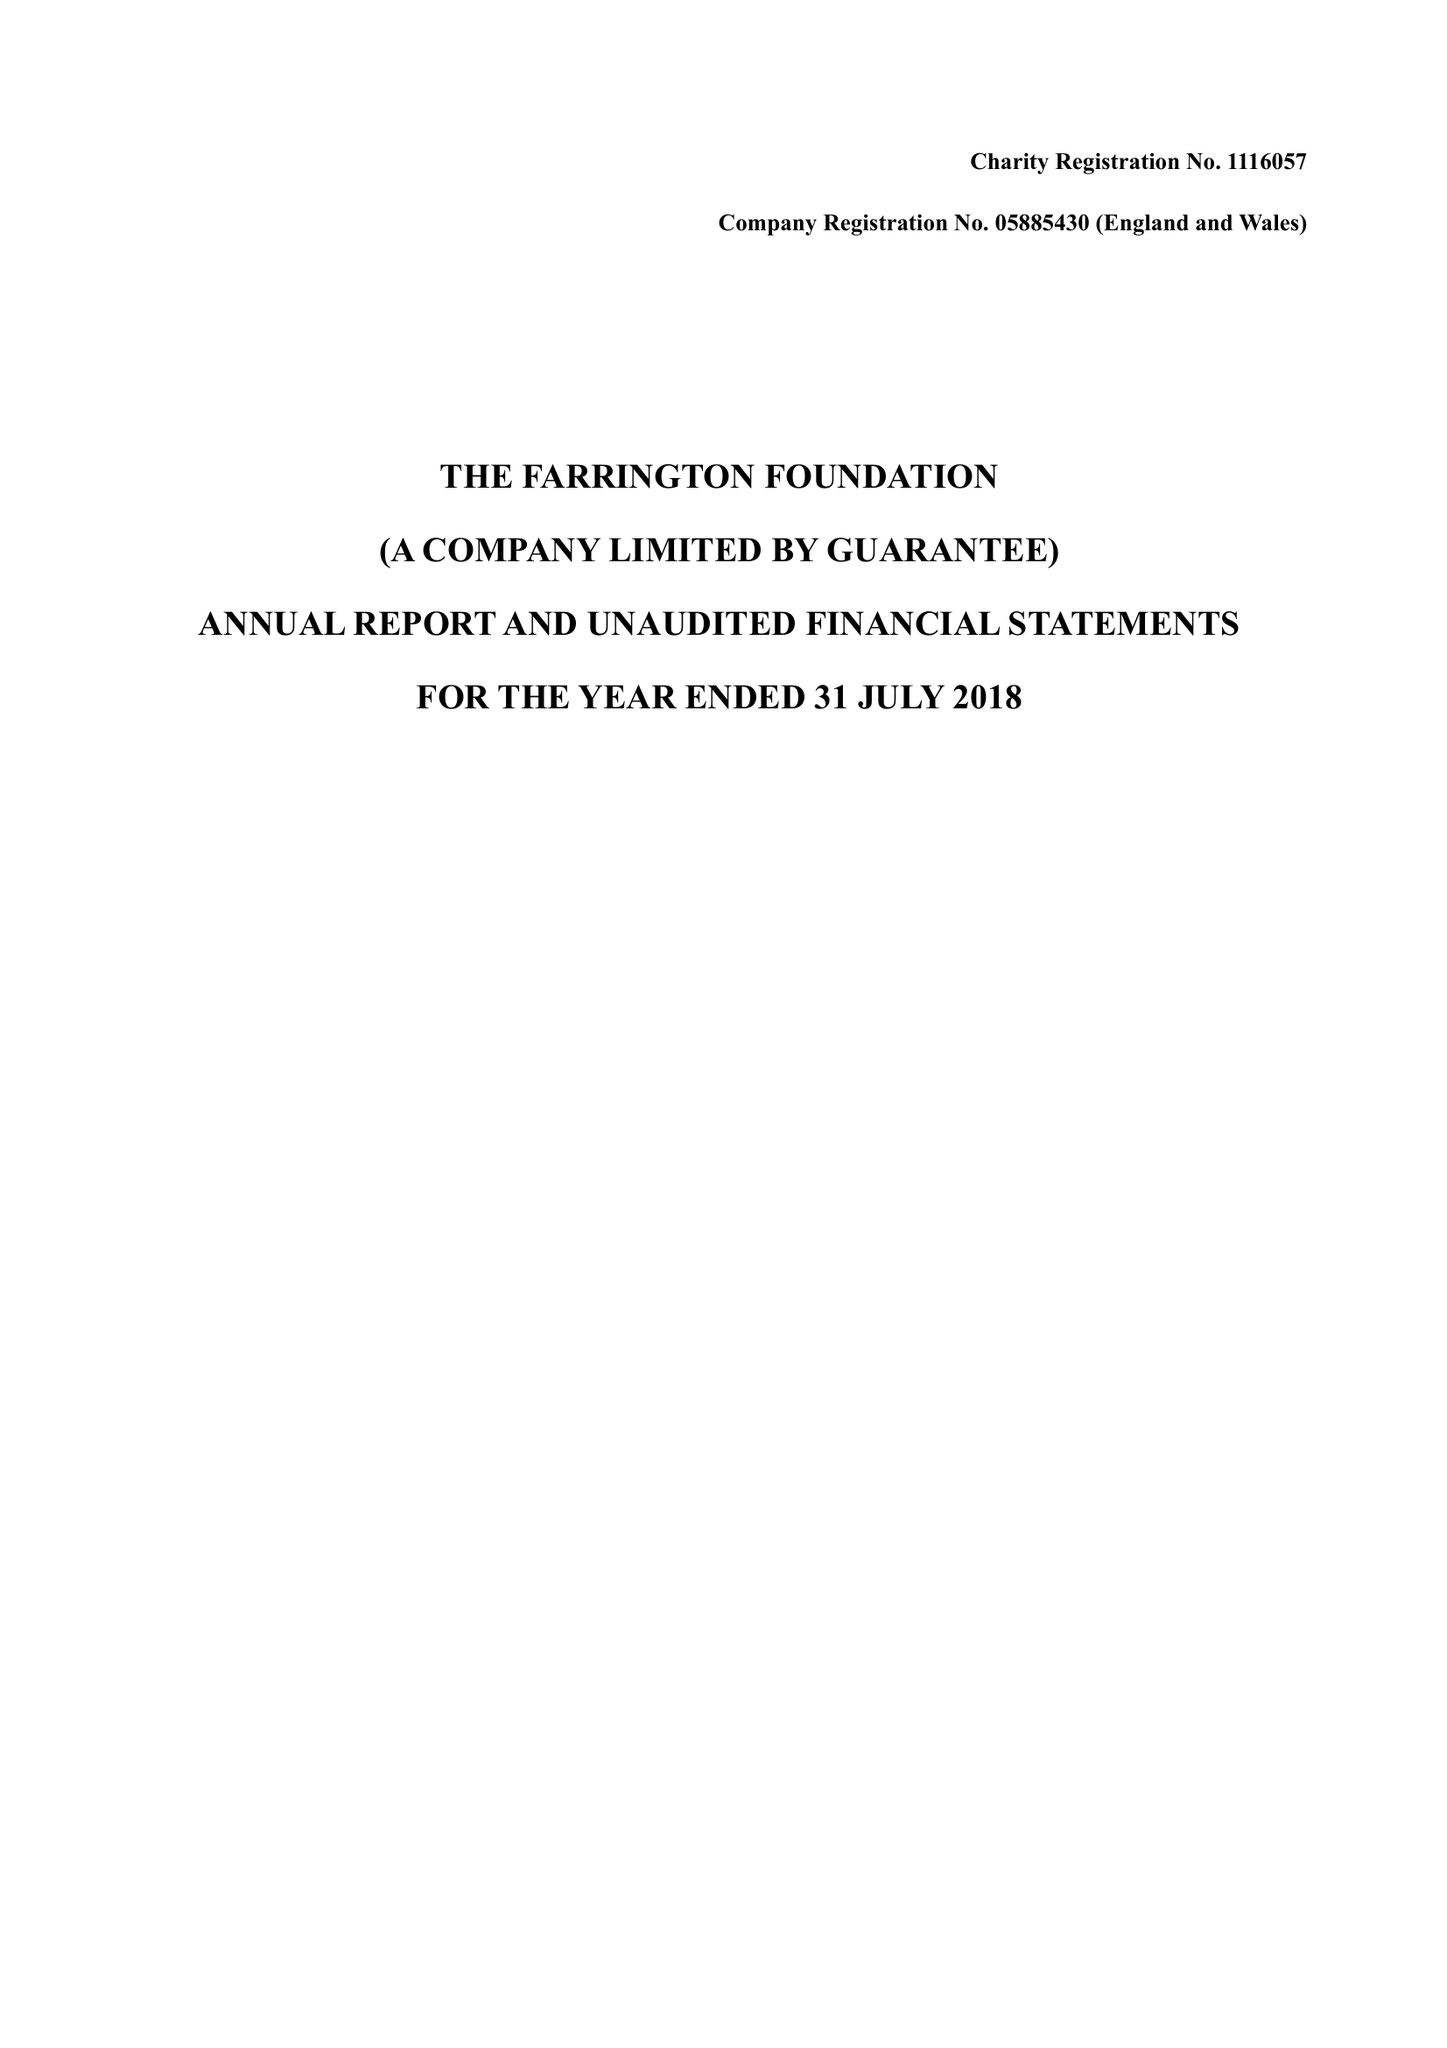What is the value for the charity_name?
Answer the question using a single word or phrase. The Farrington Foundation 